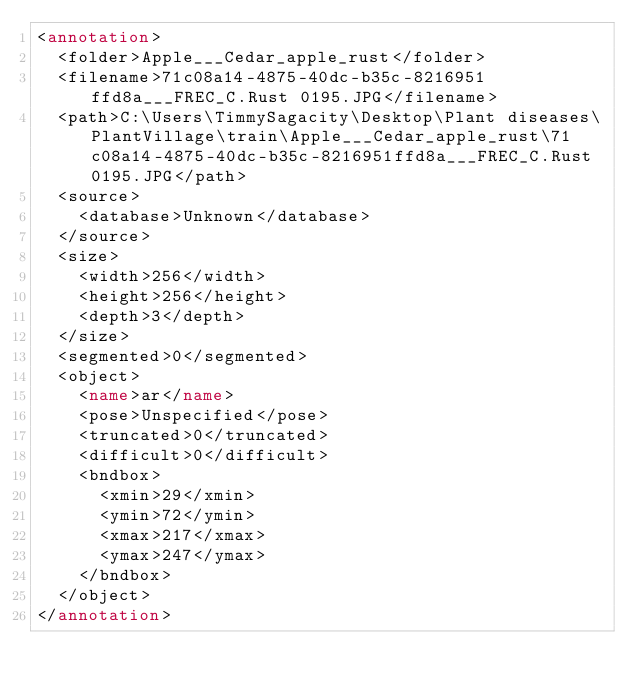<code> <loc_0><loc_0><loc_500><loc_500><_XML_><annotation>
	<folder>Apple___Cedar_apple_rust</folder>
	<filename>71c08a14-4875-40dc-b35c-8216951ffd8a___FREC_C.Rust 0195.JPG</filename>
	<path>C:\Users\TimmySagacity\Desktop\Plant diseases\PlantVillage\train\Apple___Cedar_apple_rust\71c08a14-4875-40dc-b35c-8216951ffd8a___FREC_C.Rust 0195.JPG</path>
	<source>
		<database>Unknown</database>
	</source>
	<size>
		<width>256</width>
		<height>256</height>
		<depth>3</depth>
	</size>
	<segmented>0</segmented>
	<object>
		<name>ar</name>
		<pose>Unspecified</pose>
		<truncated>0</truncated>
		<difficult>0</difficult>
		<bndbox>
			<xmin>29</xmin>
			<ymin>72</ymin>
			<xmax>217</xmax>
			<ymax>247</ymax>
		</bndbox>
	</object>
</annotation>
</code> 